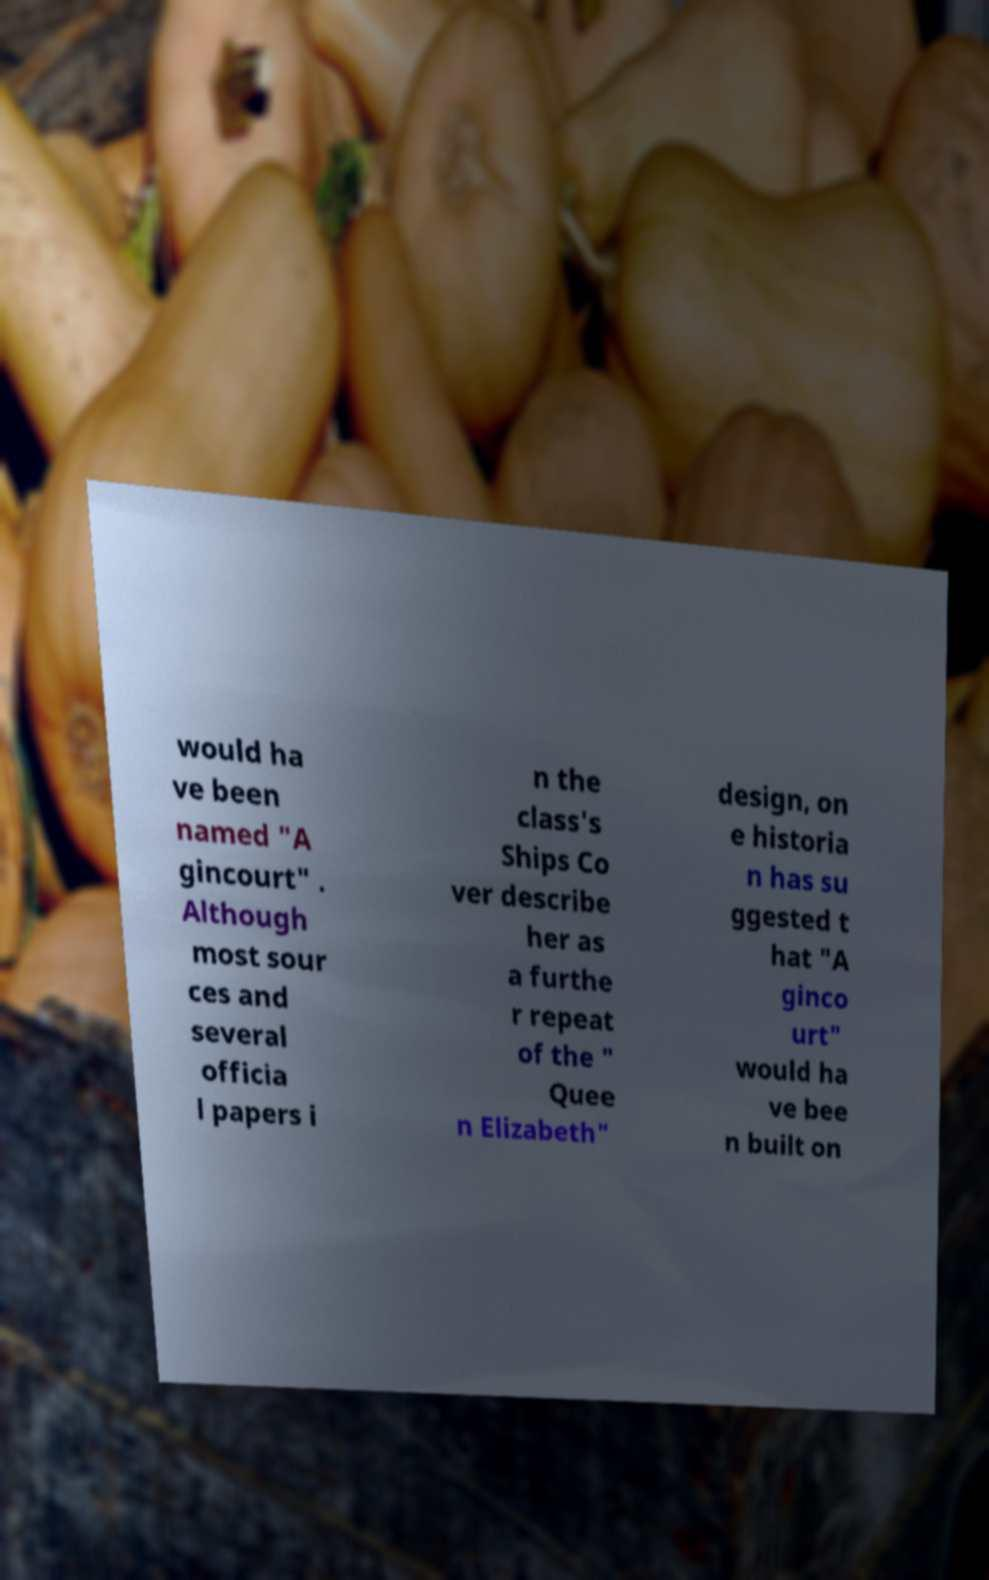For documentation purposes, I need the text within this image transcribed. Could you provide that? would ha ve been named "A gincourt" . Although most sour ces and several officia l papers i n the class's Ships Co ver describe her as a furthe r repeat of the " Quee n Elizabeth" design, on e historia n has su ggested t hat "A ginco urt" would ha ve bee n built on 